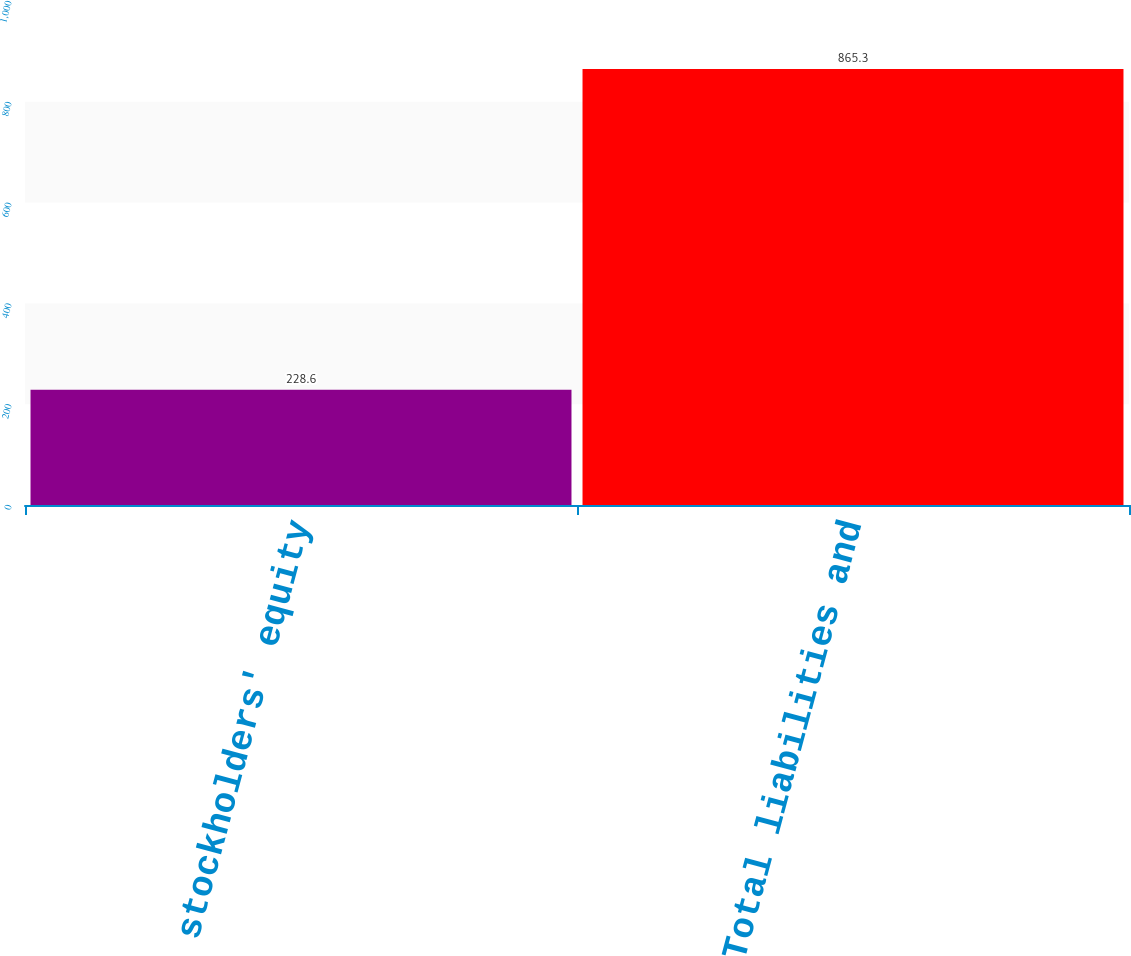Convert chart to OTSL. <chart><loc_0><loc_0><loc_500><loc_500><bar_chart><fcel>Total stockholders' equity<fcel>Total liabilities and<nl><fcel>228.6<fcel>865.3<nl></chart> 